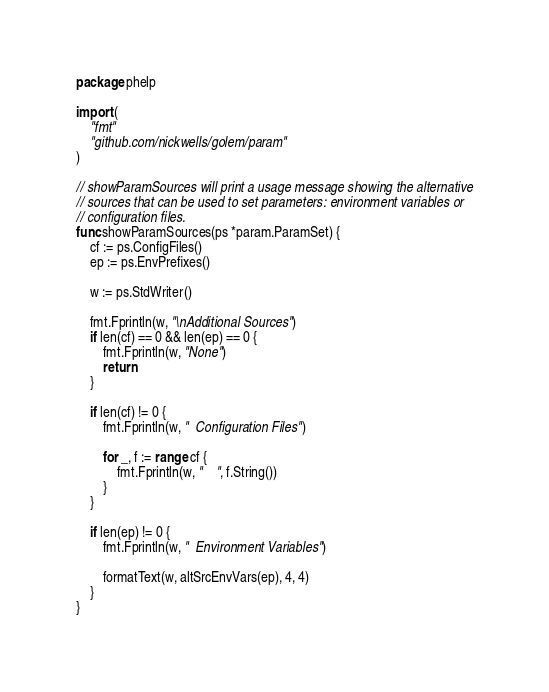Convert code to text. <code><loc_0><loc_0><loc_500><loc_500><_Go_>package phelp

import (
	"fmt"
	"github.com/nickwells/golem/param"
)

// showParamSources will print a usage message showing the alternative
// sources that can be used to set parameters: environment variables or
// configuration files.
func showParamSources(ps *param.ParamSet) {
	cf := ps.ConfigFiles()
	ep := ps.EnvPrefixes()

	w := ps.StdWriter()

	fmt.Fprintln(w, "\nAdditional Sources")
	if len(cf) == 0 && len(ep) == 0 {
		fmt.Fprintln(w, "None")
		return
	}

	if len(cf) != 0 {
		fmt.Fprintln(w, "  Configuration Files")

		for _, f := range cf {
			fmt.Fprintln(w, "    ", f.String())
		}
	}

	if len(ep) != 0 {
		fmt.Fprintln(w, "  Environment Variables")

		formatText(w, altSrcEnvVars(ep), 4, 4)
	}
}
</code> 